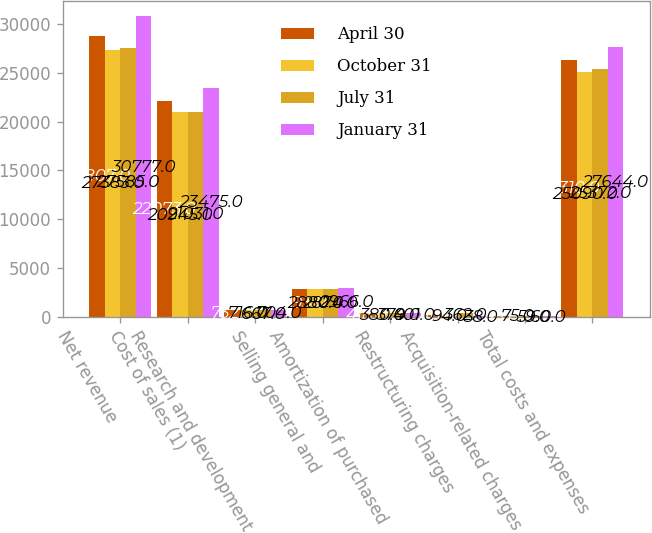<chart> <loc_0><loc_0><loc_500><loc_500><stacked_bar_chart><ecel><fcel>Net revenue<fcel>Cost of sales (1)<fcel>Research and development<fcel>Selling general and<fcel>Amortization of purchased<fcel>Restructuring charges<fcel>Acquisition-related charges<fcel>Total costs and expenses<nl><fcel>April 30<fcel>28807<fcel>22073<fcel>732<fcel>2893<fcel>418<fcel>146<fcel>48<fcel>26310<nl><fcel>October 31<fcel>27383<fcel>20945<fcel>716<fcel>2880<fcel>380<fcel>94<fcel>75<fcel>25090<nl><fcel>July 31<fcel>27585<fcel>21031<fcel>667<fcel>2874<fcel>379<fcel>362<fcel>59<fcel>25372<nl><fcel>January 31<fcel>30777<fcel>23475<fcel>704<fcel>2966<fcel>401<fcel>38<fcel>60<fcel>27644<nl></chart> 